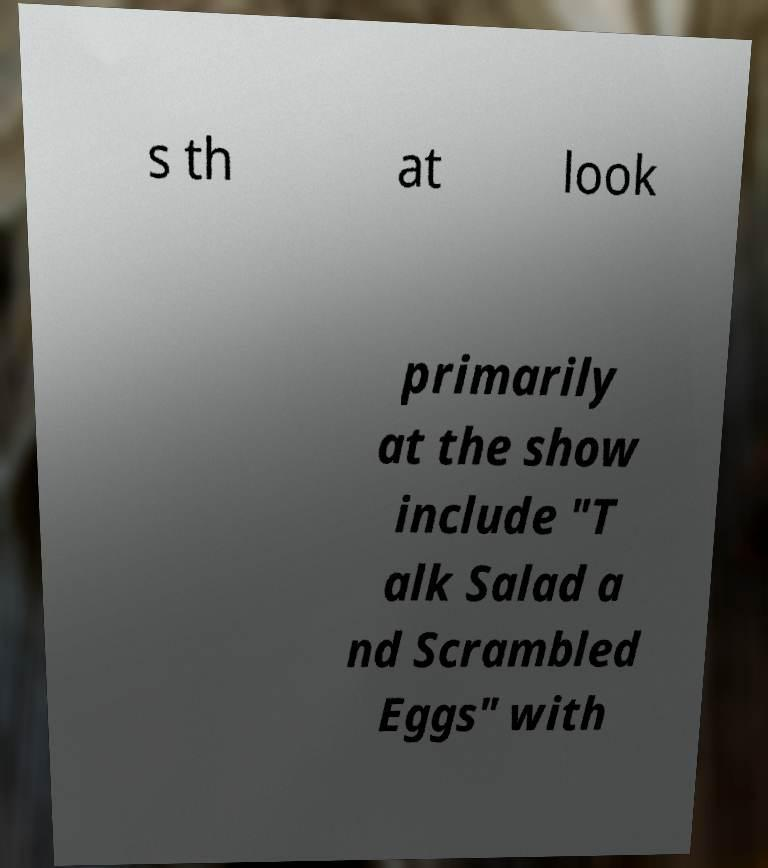I need the written content from this picture converted into text. Can you do that? s th at look primarily at the show include "T alk Salad a nd Scrambled Eggs" with 